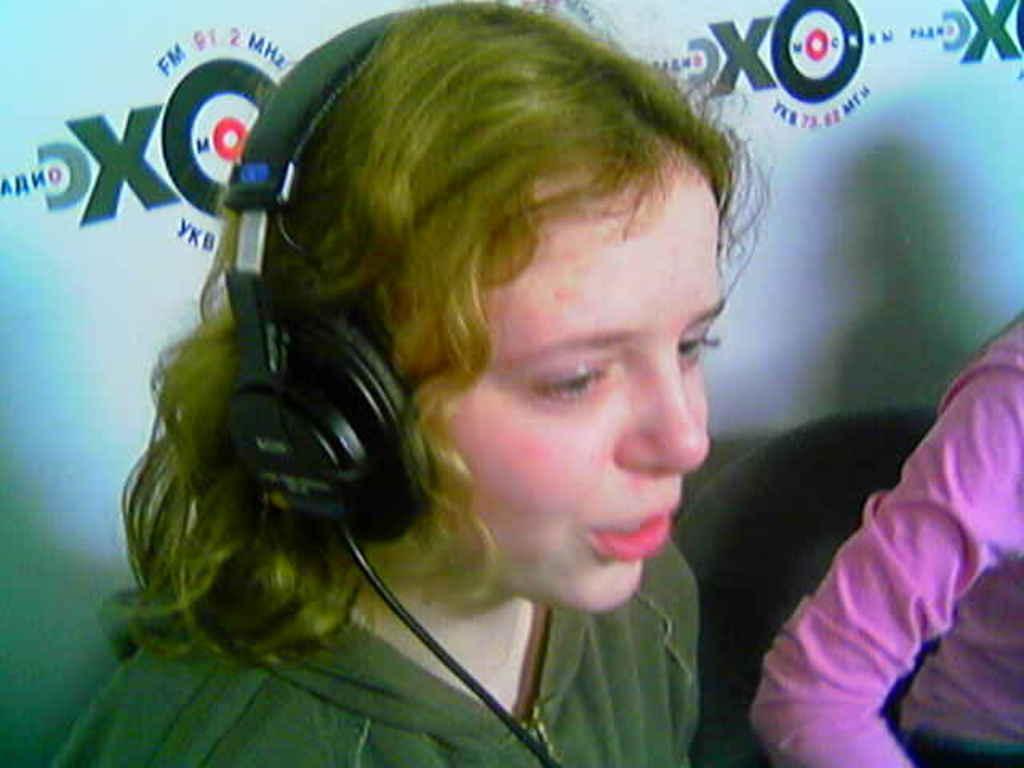Can you describe this image briefly? In this image I can see a woman wearing green colored dress and a headset which is black in color and another person wearing pink colored dress is sitting in a chair and I can see the white colored surface in the background and I can see something is printed on it. 